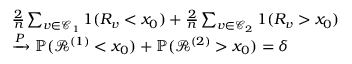<formula> <loc_0><loc_0><loc_500><loc_500>\begin{array} { r l } & { \frac { 2 } { n } \sum _ { v \in \mathcal { C } _ { 1 } } 1 ( R _ { v } < x _ { 0 } ) + \frac { 2 } { n } \sum _ { v \in \mathcal { C } _ { 2 } } 1 ( R _ { v } > x _ { 0 } ) } \\ & { \xrightarrow { P } \mathbb { P } ( { \mathcal { R } } ^ { ( 1 ) } < x _ { 0 } ) + \mathbb { P } ( { \mathcal { R } } ^ { ( 2 ) } > x _ { 0 } ) = \delta } \end{array}</formula> 